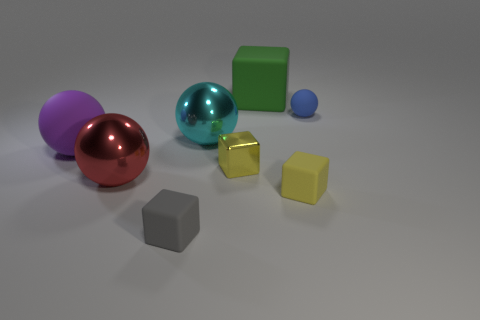What is the color of the metal sphere that is in front of the small yellow cube on the left side of the large matte thing that is to the right of the cyan ball?
Offer a very short reply. Red. What number of other things are the same material as the gray object?
Offer a very short reply. 4. There is a yellow thing that is right of the large rubber cube; does it have the same shape as the tiny blue thing?
Your answer should be compact. No. What number of tiny objects are green cubes or gray things?
Give a very brief answer. 1. Are there the same number of big rubber cubes left of the tiny yellow metal thing and large cyan metallic balls that are behind the blue thing?
Ensure brevity in your answer.  Yes. What number of other things are there of the same color as the tiny shiny block?
Provide a succinct answer. 1. There is a large matte cube; is its color the same as the rubber sphere that is to the right of the tiny gray object?
Offer a very short reply. No. What number of red things are either large spheres or cubes?
Your response must be concise. 1. Are there an equal number of big blocks that are behind the green block and tiny matte cubes?
Your answer should be very brief. No. Is there any other thing that is the same size as the red metal ball?
Provide a succinct answer. Yes. 